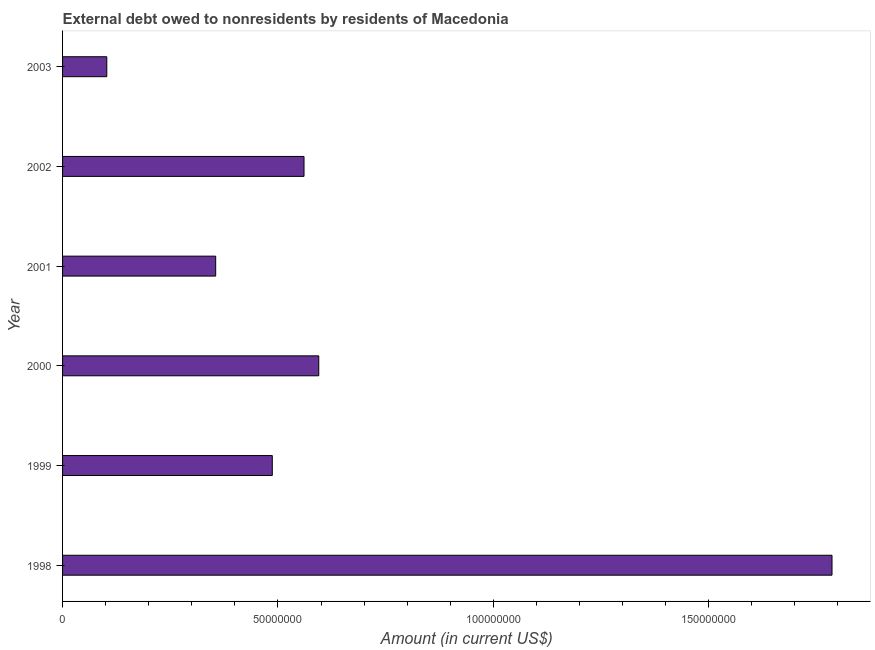Does the graph contain any zero values?
Your response must be concise. No. What is the title of the graph?
Offer a very short reply. External debt owed to nonresidents by residents of Macedonia. What is the label or title of the Y-axis?
Your answer should be very brief. Year. What is the debt in 1998?
Provide a succinct answer. 1.79e+08. Across all years, what is the maximum debt?
Your answer should be compact. 1.79e+08. Across all years, what is the minimum debt?
Offer a terse response. 1.03e+07. What is the sum of the debt?
Your answer should be compact. 3.89e+08. What is the difference between the debt in 1999 and 2003?
Keep it short and to the point. 3.84e+07. What is the average debt per year?
Your answer should be compact. 6.48e+07. What is the median debt?
Your response must be concise. 5.24e+07. What is the ratio of the debt in 1999 to that in 2002?
Your response must be concise. 0.87. Is the difference between the debt in 1998 and 2000 greater than the difference between any two years?
Offer a terse response. No. What is the difference between the highest and the second highest debt?
Your answer should be very brief. 1.19e+08. What is the difference between the highest and the lowest debt?
Provide a short and direct response. 1.68e+08. In how many years, is the debt greater than the average debt taken over all years?
Your answer should be very brief. 1. How many bars are there?
Provide a short and direct response. 6. Are all the bars in the graph horizontal?
Make the answer very short. Yes. What is the difference between two consecutive major ticks on the X-axis?
Keep it short and to the point. 5.00e+07. What is the Amount (in current US$) in 1998?
Your response must be concise. 1.79e+08. What is the Amount (in current US$) of 1999?
Keep it short and to the point. 4.87e+07. What is the Amount (in current US$) of 2000?
Give a very brief answer. 5.95e+07. What is the Amount (in current US$) in 2001?
Offer a very short reply. 3.55e+07. What is the Amount (in current US$) in 2002?
Your answer should be compact. 5.61e+07. What is the Amount (in current US$) in 2003?
Ensure brevity in your answer.  1.03e+07. What is the difference between the Amount (in current US$) in 1998 and 1999?
Offer a very short reply. 1.30e+08. What is the difference between the Amount (in current US$) in 1998 and 2000?
Give a very brief answer. 1.19e+08. What is the difference between the Amount (in current US$) in 1998 and 2001?
Provide a short and direct response. 1.43e+08. What is the difference between the Amount (in current US$) in 1998 and 2002?
Keep it short and to the point. 1.23e+08. What is the difference between the Amount (in current US$) in 1998 and 2003?
Your answer should be compact. 1.68e+08. What is the difference between the Amount (in current US$) in 1999 and 2000?
Provide a short and direct response. -1.08e+07. What is the difference between the Amount (in current US$) in 1999 and 2001?
Provide a short and direct response. 1.31e+07. What is the difference between the Amount (in current US$) in 1999 and 2002?
Offer a terse response. -7.36e+06. What is the difference between the Amount (in current US$) in 1999 and 2003?
Provide a succinct answer. 3.84e+07. What is the difference between the Amount (in current US$) in 2000 and 2001?
Keep it short and to the point. 2.39e+07. What is the difference between the Amount (in current US$) in 2000 and 2002?
Give a very brief answer. 3.43e+06. What is the difference between the Amount (in current US$) in 2000 and 2003?
Your answer should be very brief. 4.92e+07. What is the difference between the Amount (in current US$) in 2001 and 2002?
Offer a very short reply. -2.05e+07. What is the difference between the Amount (in current US$) in 2001 and 2003?
Make the answer very short. 2.53e+07. What is the difference between the Amount (in current US$) in 2002 and 2003?
Ensure brevity in your answer.  4.58e+07. What is the ratio of the Amount (in current US$) in 1998 to that in 1999?
Provide a short and direct response. 3.67. What is the ratio of the Amount (in current US$) in 1998 to that in 2000?
Your answer should be very brief. 3. What is the ratio of the Amount (in current US$) in 1998 to that in 2001?
Provide a short and direct response. 5.03. What is the ratio of the Amount (in current US$) in 1998 to that in 2002?
Ensure brevity in your answer.  3.19. What is the ratio of the Amount (in current US$) in 1998 to that in 2003?
Offer a terse response. 17.4. What is the ratio of the Amount (in current US$) in 1999 to that in 2000?
Provide a short and direct response. 0.82. What is the ratio of the Amount (in current US$) in 1999 to that in 2001?
Provide a short and direct response. 1.37. What is the ratio of the Amount (in current US$) in 1999 to that in 2002?
Provide a succinct answer. 0.87. What is the ratio of the Amount (in current US$) in 1999 to that in 2003?
Provide a succinct answer. 4.74. What is the ratio of the Amount (in current US$) in 2000 to that in 2001?
Provide a succinct answer. 1.67. What is the ratio of the Amount (in current US$) in 2000 to that in 2002?
Keep it short and to the point. 1.06. What is the ratio of the Amount (in current US$) in 2000 to that in 2003?
Ensure brevity in your answer.  5.79. What is the ratio of the Amount (in current US$) in 2001 to that in 2002?
Your answer should be compact. 0.63. What is the ratio of the Amount (in current US$) in 2001 to that in 2003?
Make the answer very short. 3.46. What is the ratio of the Amount (in current US$) in 2002 to that in 2003?
Give a very brief answer. 5.46. 